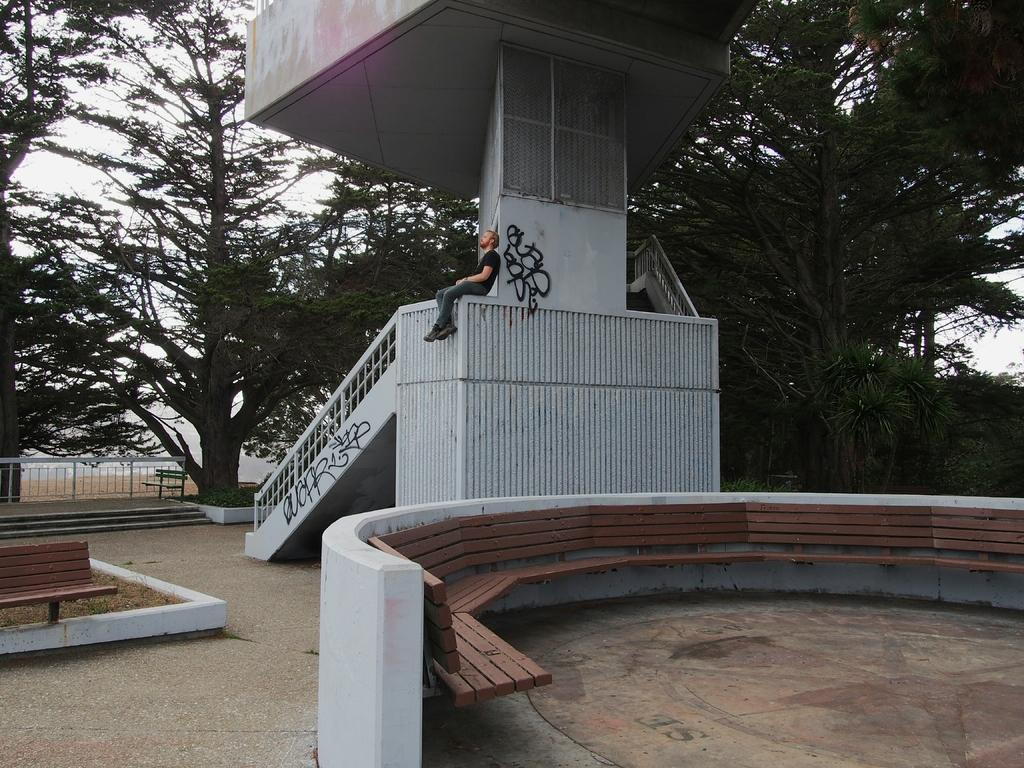What is the person in the image doing? The person is sitting on the wall in the image. What architectural feature can be seen in the image? There is a pillar in the image. What is a feature that allows for movement between different levels in the image? There are stairs in the image. What safety feature is present in the image? There is a railing in the image. What type of seating is available on the ground in the image? There is a bench on the ground in the image. What type of seating is attached to the wall in the image? There are benches attached to the wall in the image. What can be seen in the background of the image? There are trees and the sky visible in the background of the image. How does the person in the image expand their knowledge about quantum physics? The image does not provide any information about the person's knowledge of quantum physics or any means of expanding it. 